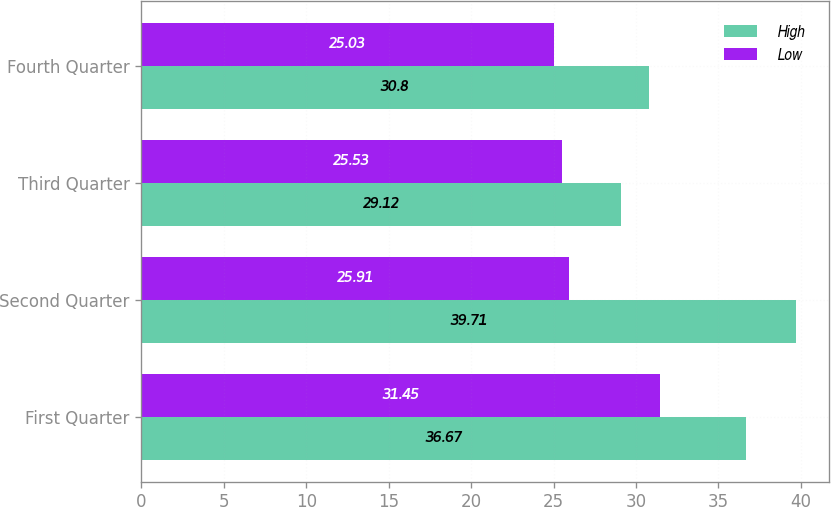Convert chart to OTSL. <chart><loc_0><loc_0><loc_500><loc_500><stacked_bar_chart><ecel><fcel>First Quarter<fcel>Second Quarter<fcel>Third Quarter<fcel>Fourth Quarter<nl><fcel>High<fcel>36.67<fcel>39.71<fcel>29.12<fcel>30.8<nl><fcel>Low<fcel>31.45<fcel>25.91<fcel>25.53<fcel>25.03<nl></chart> 